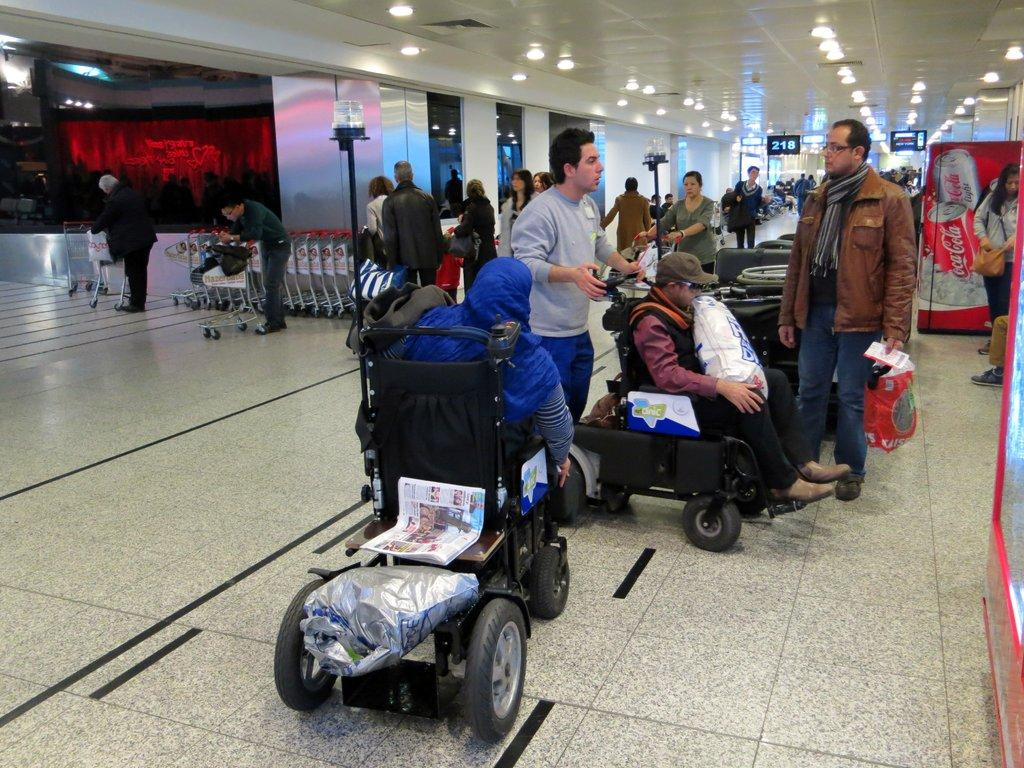<image>
Present a compact description of the photo's key features. many people near a sign that says 218 in an airport 